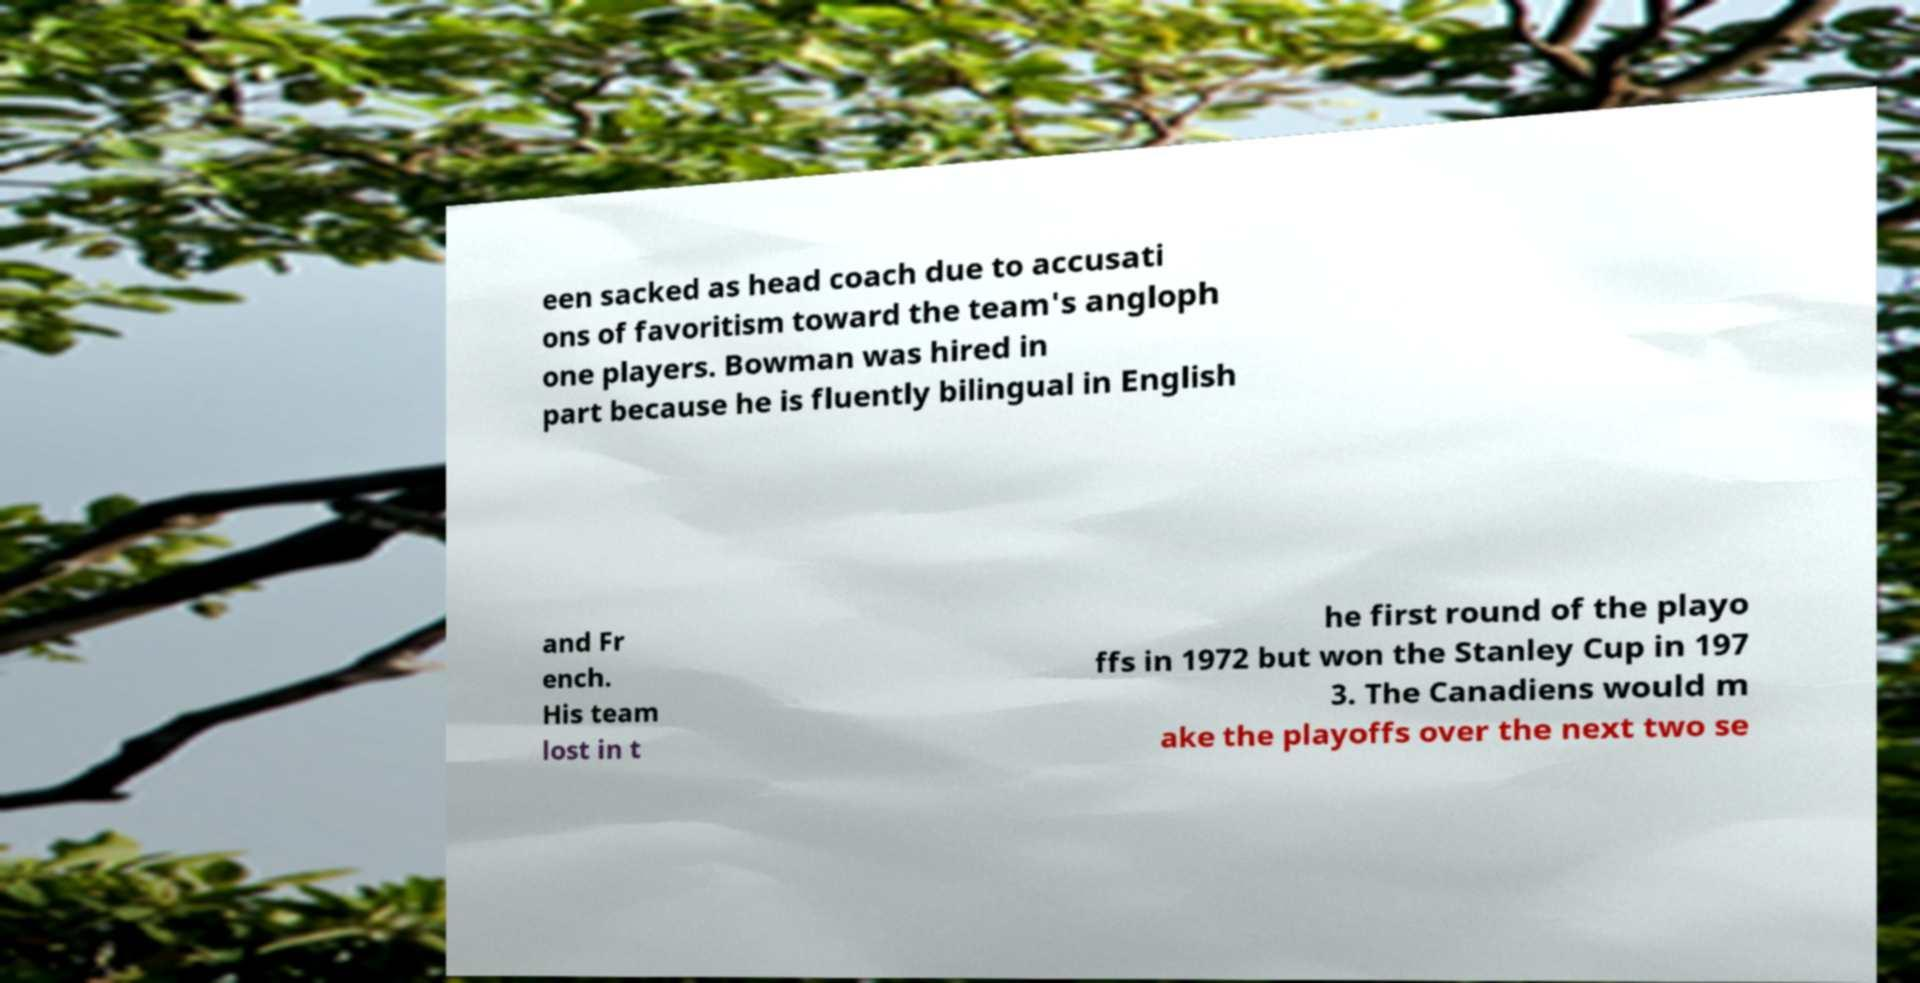Can you accurately transcribe the text from the provided image for me? een sacked as head coach due to accusati ons of favoritism toward the team's angloph one players. Bowman was hired in part because he is fluently bilingual in English and Fr ench. His team lost in t he first round of the playo ffs in 1972 but won the Stanley Cup in 197 3. The Canadiens would m ake the playoffs over the next two se 